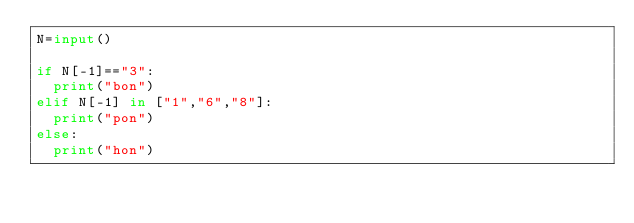<code> <loc_0><loc_0><loc_500><loc_500><_Python_>N=input()

if N[-1]=="3":
	print("bon")
elif N[-1] in ["1","6","8"]:
	print("pon")
else:
	print("hon")</code> 